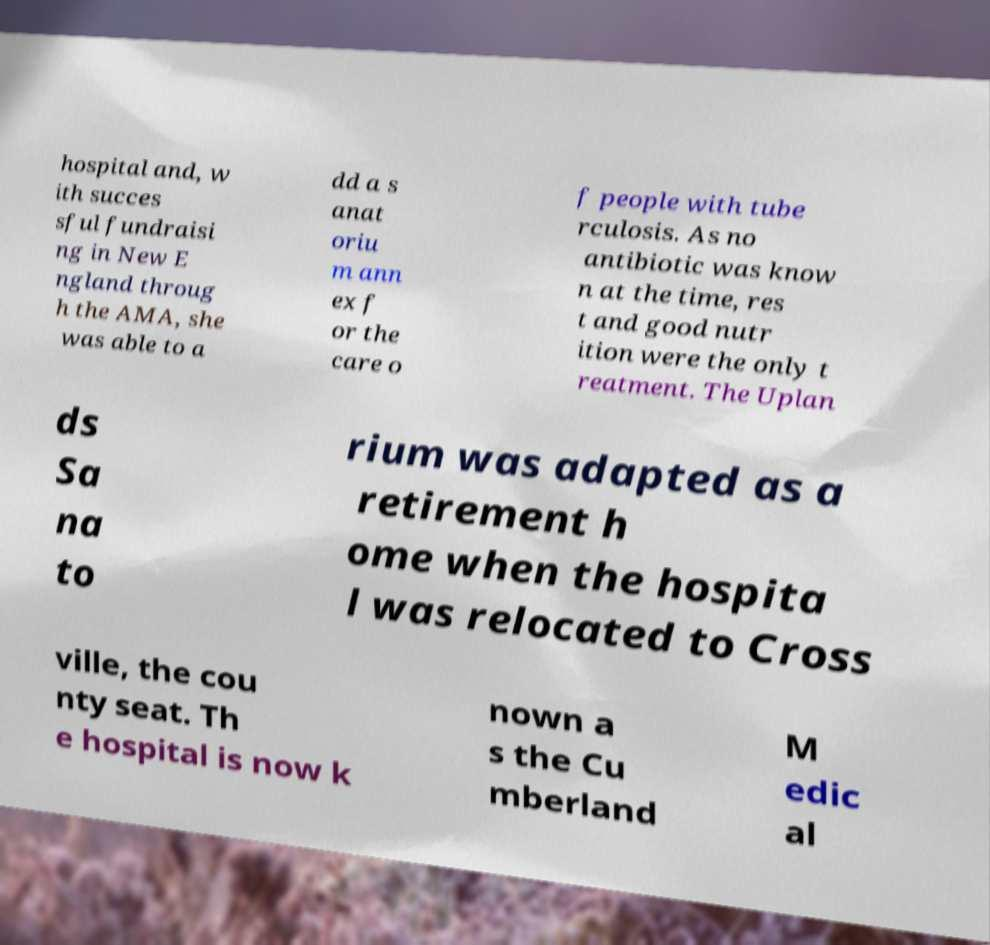There's text embedded in this image that I need extracted. Can you transcribe it verbatim? hospital and, w ith succes sful fundraisi ng in New E ngland throug h the AMA, she was able to a dd a s anat oriu m ann ex f or the care o f people with tube rculosis. As no antibiotic was know n at the time, res t and good nutr ition were the only t reatment. The Uplan ds Sa na to rium was adapted as a retirement h ome when the hospita l was relocated to Cross ville, the cou nty seat. Th e hospital is now k nown a s the Cu mberland M edic al 